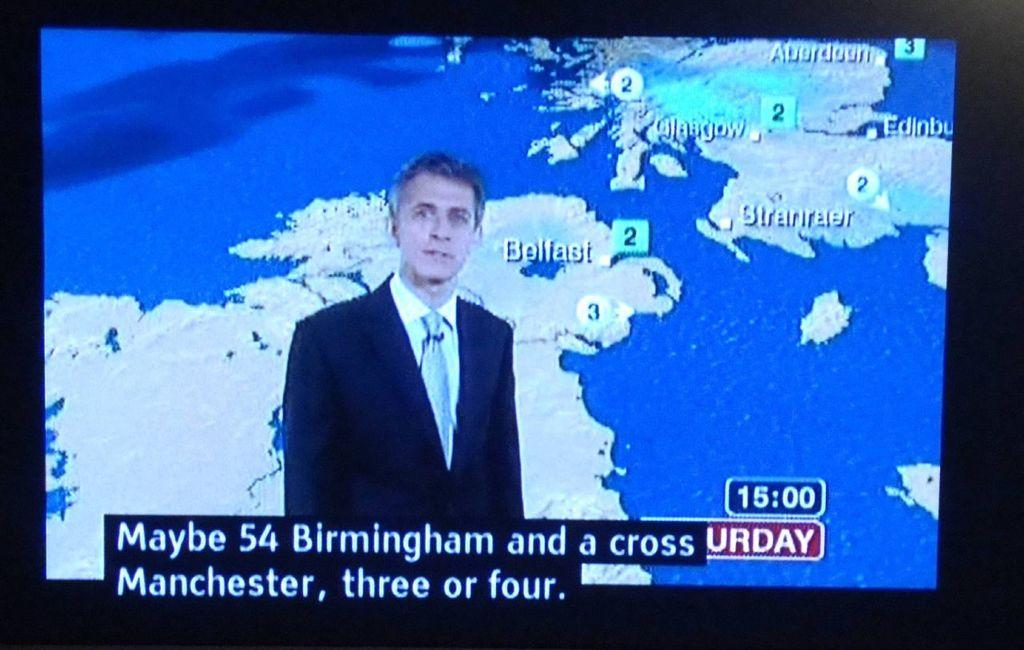<image>
Share a concise interpretation of the image provided. The man reporting the Saturday weather is dressed in a dark suit jacket with a tie. 